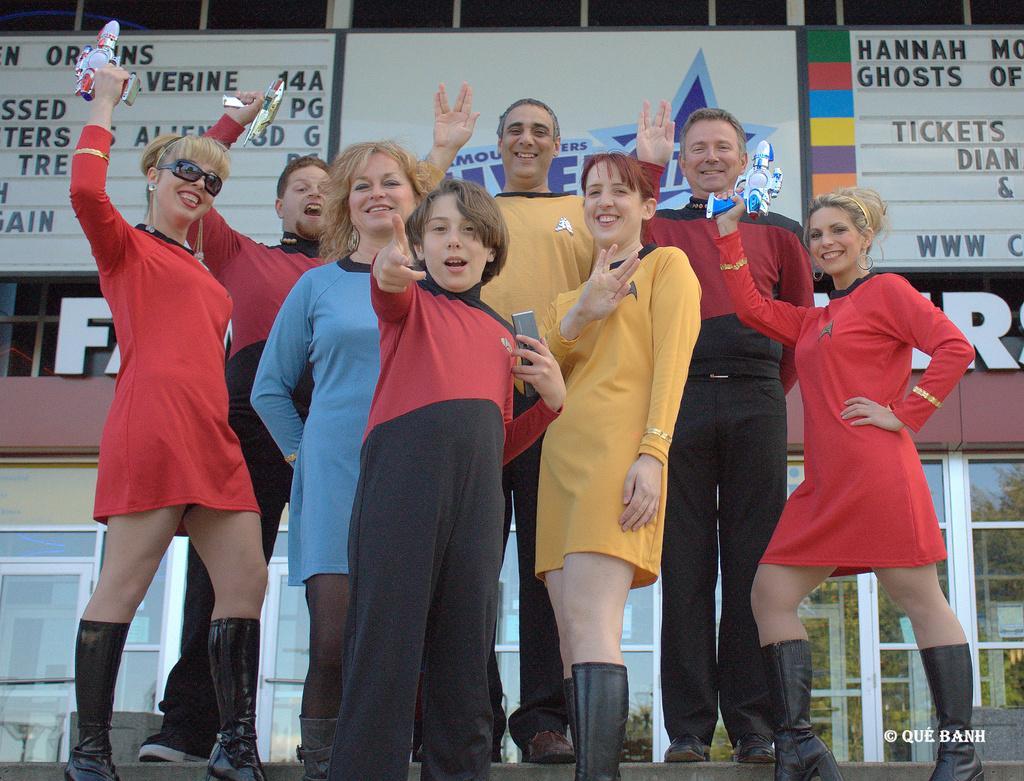How would you summarize this image in a sentence or two? This picture describe about the group of girls standing and some are holding the toy gun in the hand and giving the pose into the camera with smile. Behind there are two scoreboard and one advertisement board. 